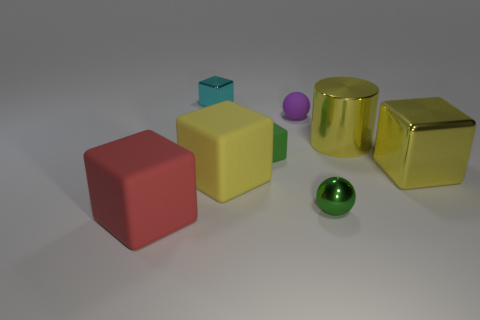Is there anything else that has the same shape as the tiny cyan shiny object?
Provide a short and direct response. Yes. The other shiny object that is the same shape as the cyan metal thing is what color?
Make the answer very short. Yellow. How many things are either red rubber things or big things right of the large red matte block?
Offer a terse response. 4. Are there fewer small spheres left of the small green matte cube than large blue cylinders?
Offer a terse response. No. There is a ball that is in front of the block to the right of the small metal thing in front of the small rubber ball; how big is it?
Your response must be concise. Small. The object that is to the left of the yellow rubber block and in front of the yellow metallic block is what color?
Offer a terse response. Red. How many cyan rubber spheres are there?
Your answer should be compact. 0. Is the material of the large cylinder the same as the green sphere?
Ensure brevity in your answer.  Yes. There is a cube on the right side of the small green matte block; does it have the same size as the block to the left of the cyan shiny cube?
Offer a very short reply. Yes. Is the number of green cubes less than the number of green matte cylinders?
Your answer should be very brief. No. 